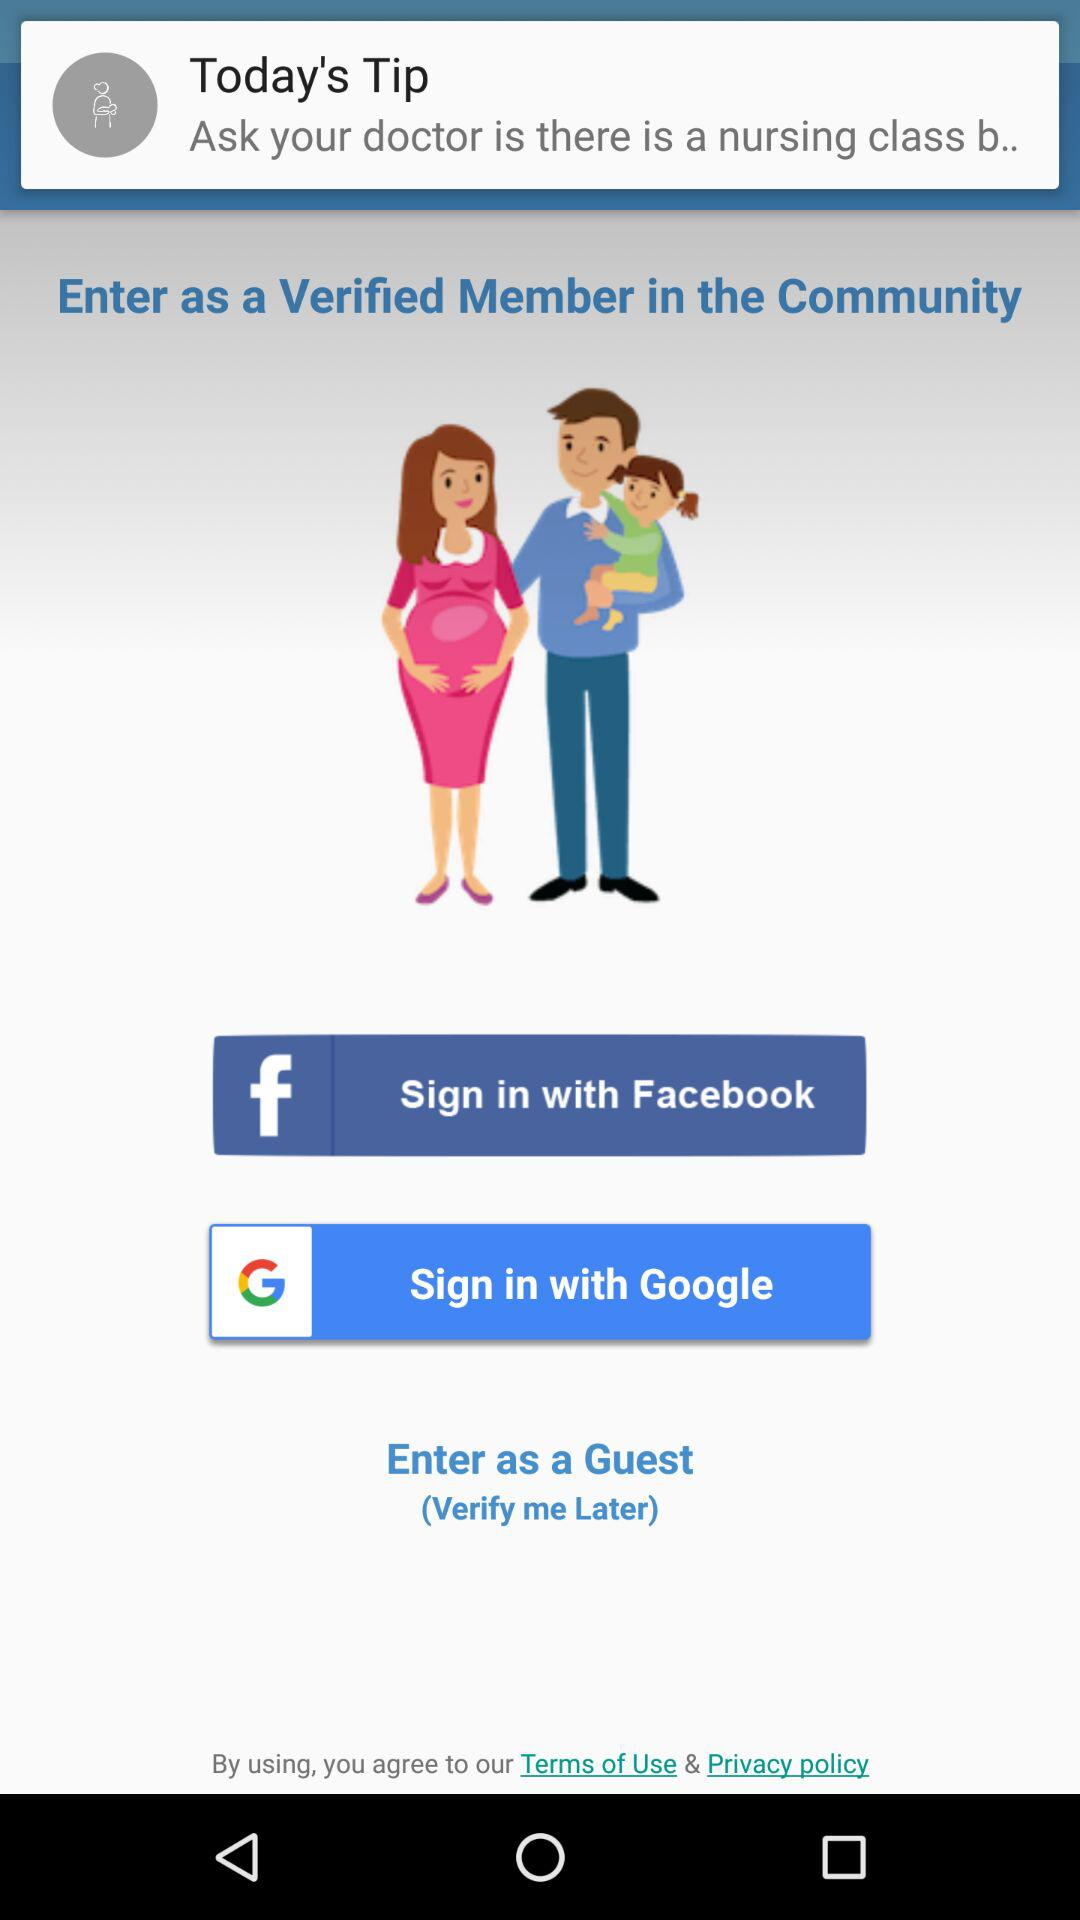What accounts can I use to sign in? You can use "Facebook" and "Google" accounts. 